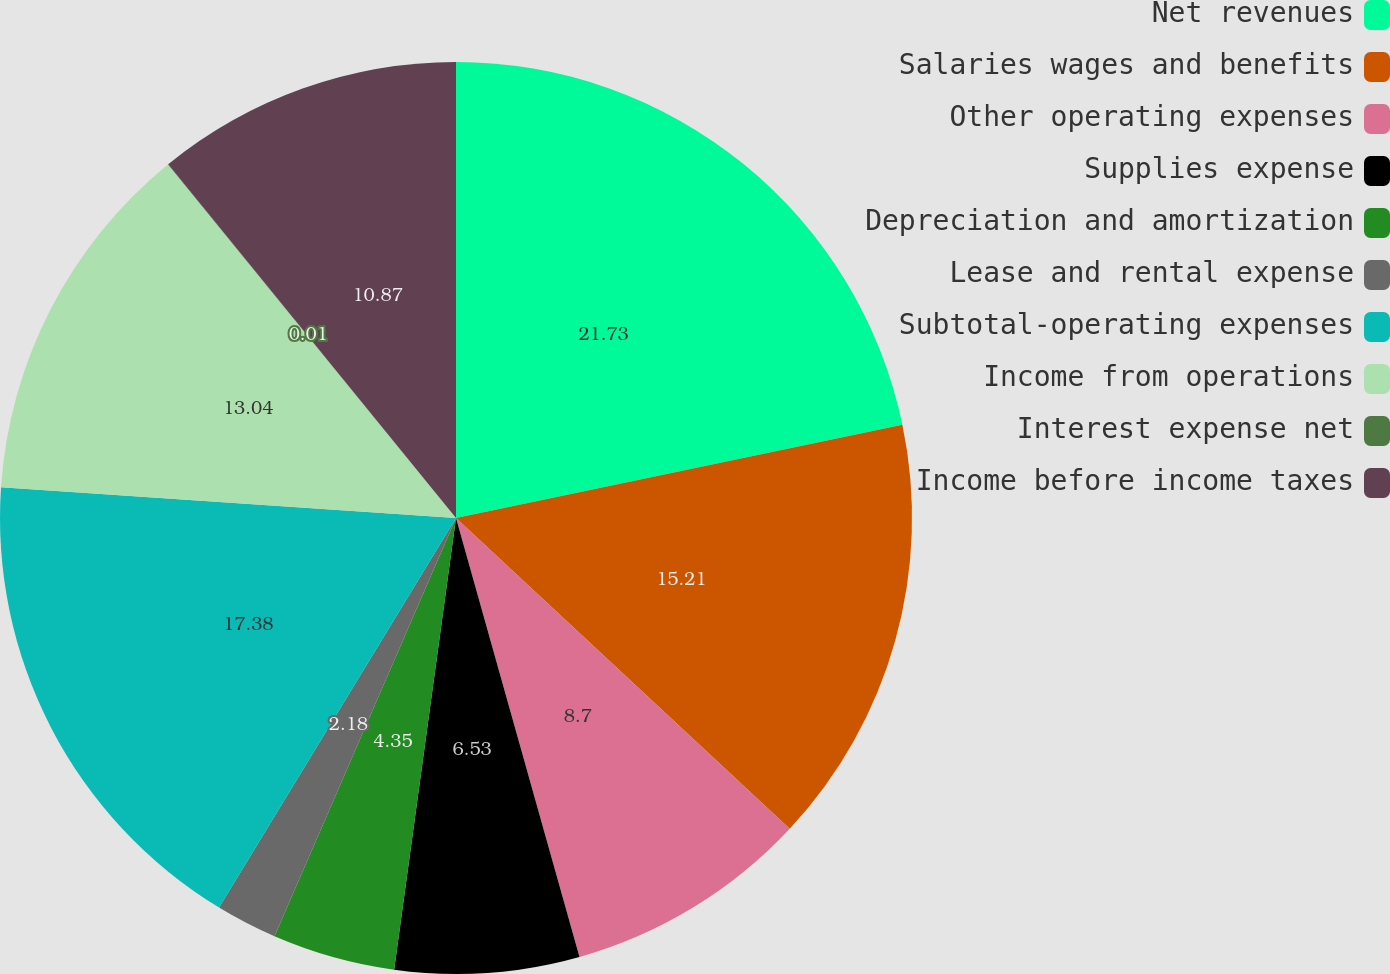Convert chart. <chart><loc_0><loc_0><loc_500><loc_500><pie_chart><fcel>Net revenues<fcel>Salaries wages and benefits<fcel>Other operating expenses<fcel>Supplies expense<fcel>Depreciation and amortization<fcel>Lease and rental expense<fcel>Subtotal-operating expenses<fcel>Income from operations<fcel>Interest expense net<fcel>Income before income taxes<nl><fcel>21.72%<fcel>15.21%<fcel>8.7%<fcel>6.53%<fcel>4.35%<fcel>2.18%<fcel>17.38%<fcel>13.04%<fcel>0.01%<fcel>10.87%<nl></chart> 